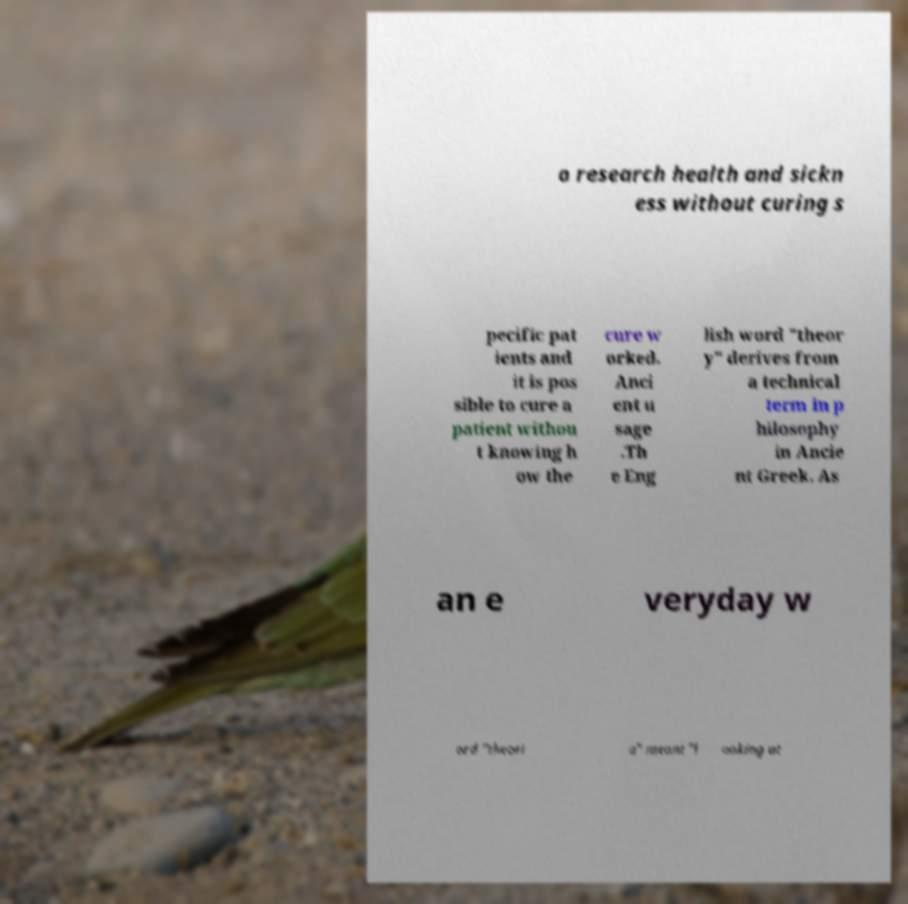There's text embedded in this image that I need extracted. Can you transcribe it verbatim? o research health and sickn ess without curing s pecific pat ients and it is pos sible to cure a patient withou t knowing h ow the cure w orked. Anci ent u sage .Th e Eng lish word "theor y" derives from a technical term in p hilosophy in Ancie nt Greek. As an e veryday w ord "theori a" meant "l ooking at 